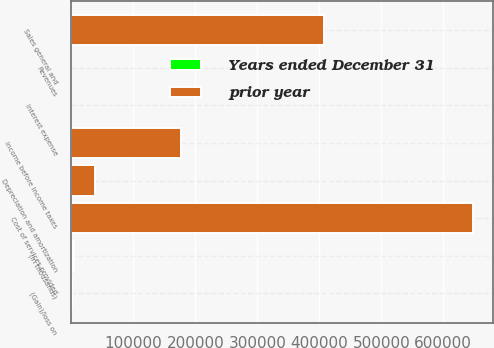Convert chart to OTSL. <chart><loc_0><loc_0><loc_500><loc_500><stacked_bar_chart><ecel><fcel>(in thousands)<fcel>Revenues<fcel>Cost of services provided<fcel>Depreciation and amortization<fcel>Sales general and<fcel>(Gain)/loss on<fcel>Interest expense<fcel>Income before income taxes<nl><fcel>prior year<fcel>2012<fcel>215.6<fcel>647578<fcel>38655<fcel>407488<fcel>468<fcel>14<fcel>176642<nl><fcel>Years ended December 31<fcel>2012<fcel>5.5<fcel>5<fcel>3.1<fcel>4.8<fcel>215.6<fcel>97.2<fcel>9.7<nl></chart> 